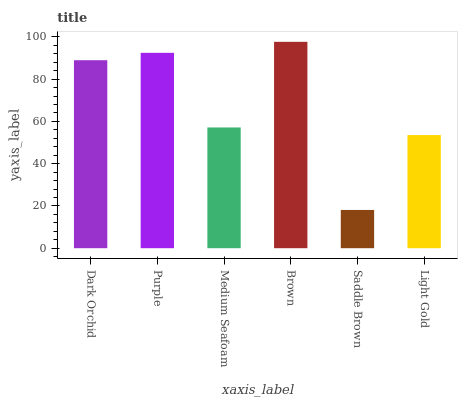Is Brown the maximum?
Answer yes or no. Yes. Is Purple the minimum?
Answer yes or no. No. Is Purple the maximum?
Answer yes or no. No. Is Purple greater than Dark Orchid?
Answer yes or no. Yes. Is Dark Orchid less than Purple?
Answer yes or no. Yes. Is Dark Orchid greater than Purple?
Answer yes or no. No. Is Purple less than Dark Orchid?
Answer yes or no. No. Is Dark Orchid the high median?
Answer yes or no. Yes. Is Medium Seafoam the low median?
Answer yes or no. Yes. Is Light Gold the high median?
Answer yes or no. No. Is Saddle Brown the low median?
Answer yes or no. No. 